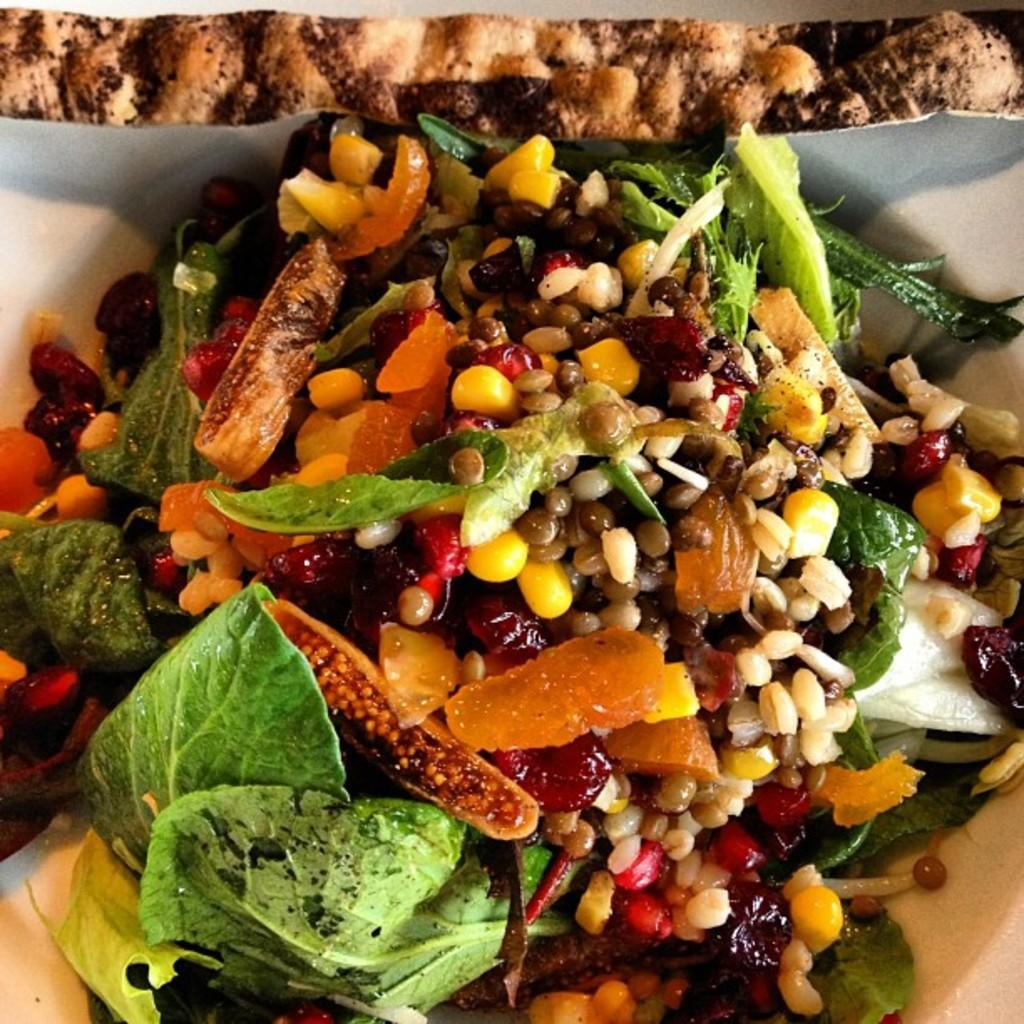What type of food item is present in the image? There is a food item with vegetable garnish in the image. What other ingredients can be seen in the image? There are grains and corns visible in the image. Can you describe the vegetable garnish on the food item? Unfortunately, the facts provided do not give enough detail to describe the vegetable garnish. Is there a specific part of the food item that is visible in the image? Yes, there is a part of the food item is visible in the image. What type of friction is present between the grains and corns in the image? There is no information provided about friction between the grains and corns in the image. Can you describe the voyage of the food item in the image? There is no information provided about the food item's journey or voyage in the image. 